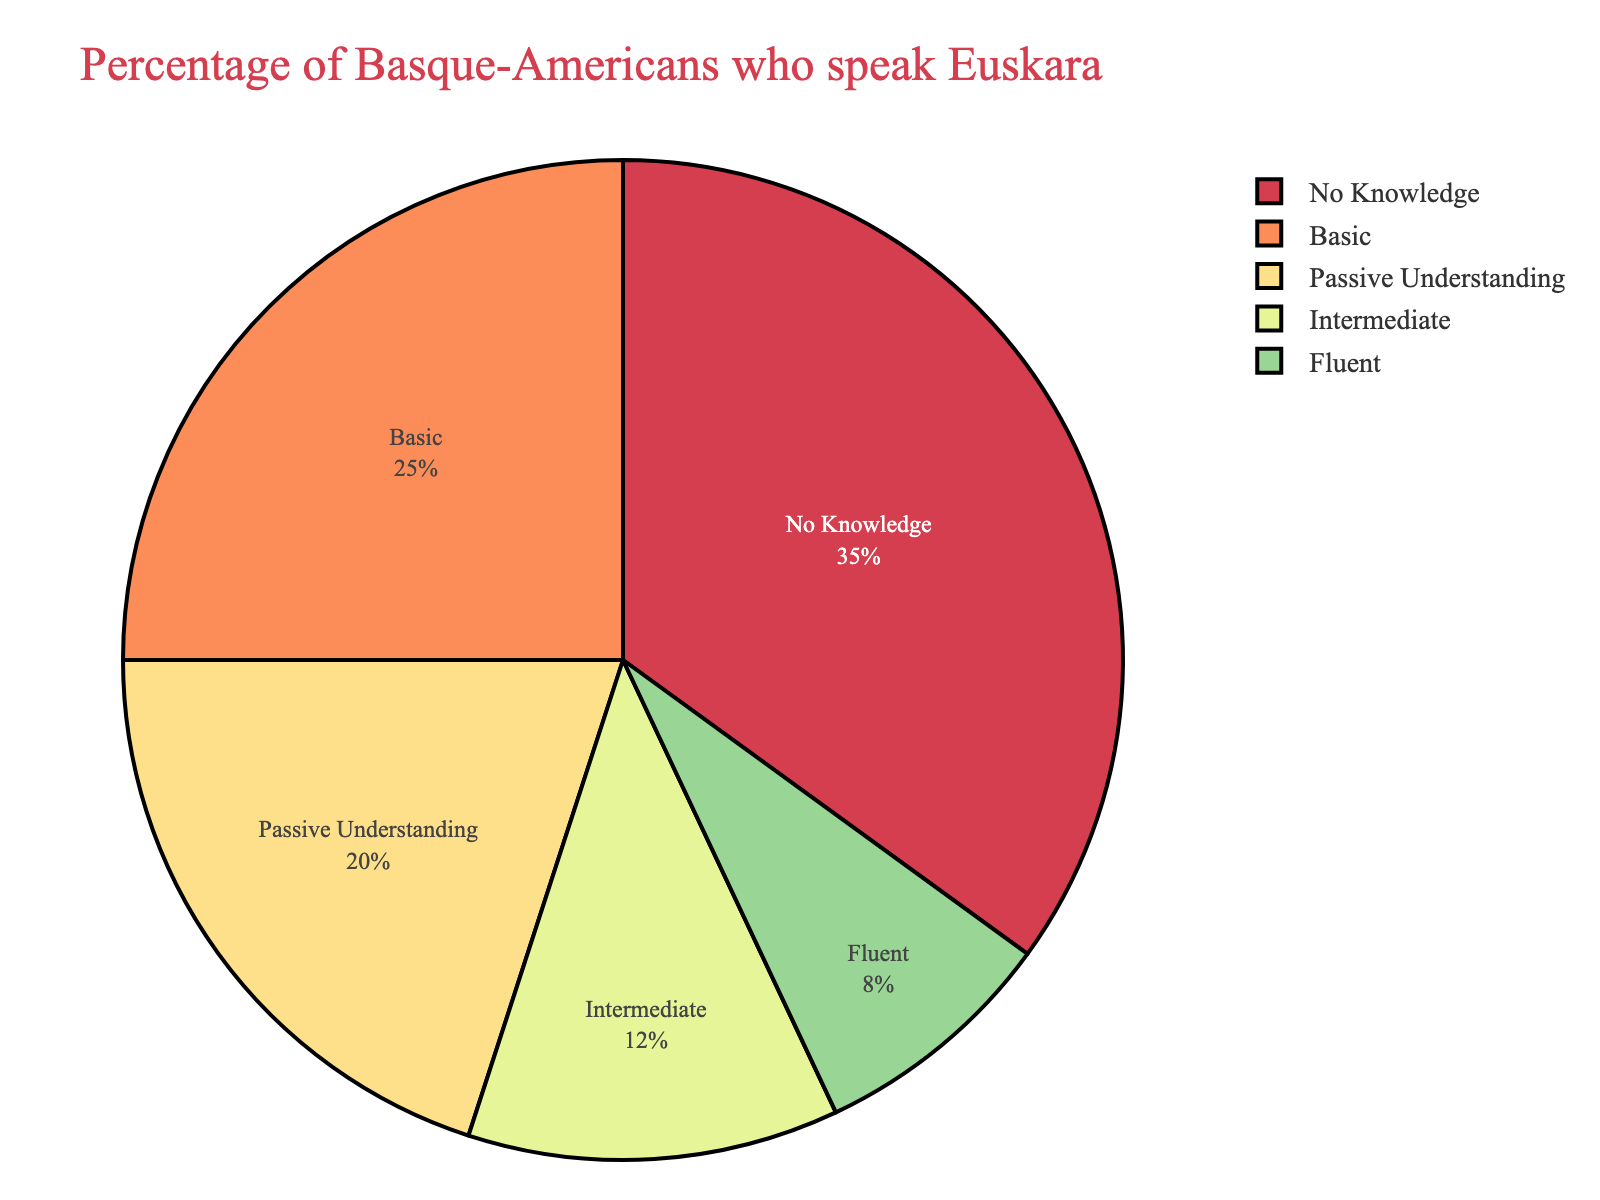What is the percentage of Basque-Americans who have no knowledge of Euskara? The section labeled "No Knowledge" on the pie chart represents the percentage of Basque-Americans who do not speak Euskara.
Answer: 35 Which proficiency level has the smallest percentage? The smallest percentage slice on the pie chart is labeled "Fluent," indicating it has the lowest percentage.
Answer: Fluent What percentage of Basque-Americans have at least a basic understanding of Euskara? To determine this, sum the percentages of the "Basic," "Intermediate," and "Fluent" proficiency levels. 8 + 12 + 25 = 45
Answer: 45 Compare the percentage of Basque-Americans with passive understanding of Euskara to those with basic understanding. Which group is larger, and by how much? The pie chart shows "Passive Understanding" at 20% and "Basic" at 25%. The basic proficiency group is larger. 25 - 20 = 5
Answer: Basic, by 5% Is the percentage of Basque-Americans with intermediate proficiency greater than those with fluent proficiency? The pie chart shows 12% for intermediate proficiency and 8% for fluent proficiency. 12 > 8
Answer: Yes What is the combined percentage of Basque-Americans with either intermediate or fluent proficiency? Sum the percentages of the "Intermediate" and "Fluent" proficiency levels. 12 + 8 = 20
Answer: 20% How much larger is the percentage of Basque-Americans who have basic knowledge compared to those with no knowledge? Subtract the percentage of "No Knowledge" from "Basic." 35 - 25 = 10
Answer: No Knowledge, by 10% What portion of the pie chart does the "Passive Understanding" slice visually represent? The pie chart shows "Passive Understanding" represents 20%, as indicated by its slice.
Answer: 20% Which color represents the highest proficiency level on the pie chart? The pie chart uses different colors for each proficiency level. The color corresponding to "Fluent" proficiency is red.
Answer: Red What is the sum of percentages for Basque-Americans who have either passive understanding or no knowledge of Euskara? Add the percentages of "Passive Understanding" and "No Knowledge." 20 + 35 = 55
Answer: 55% 